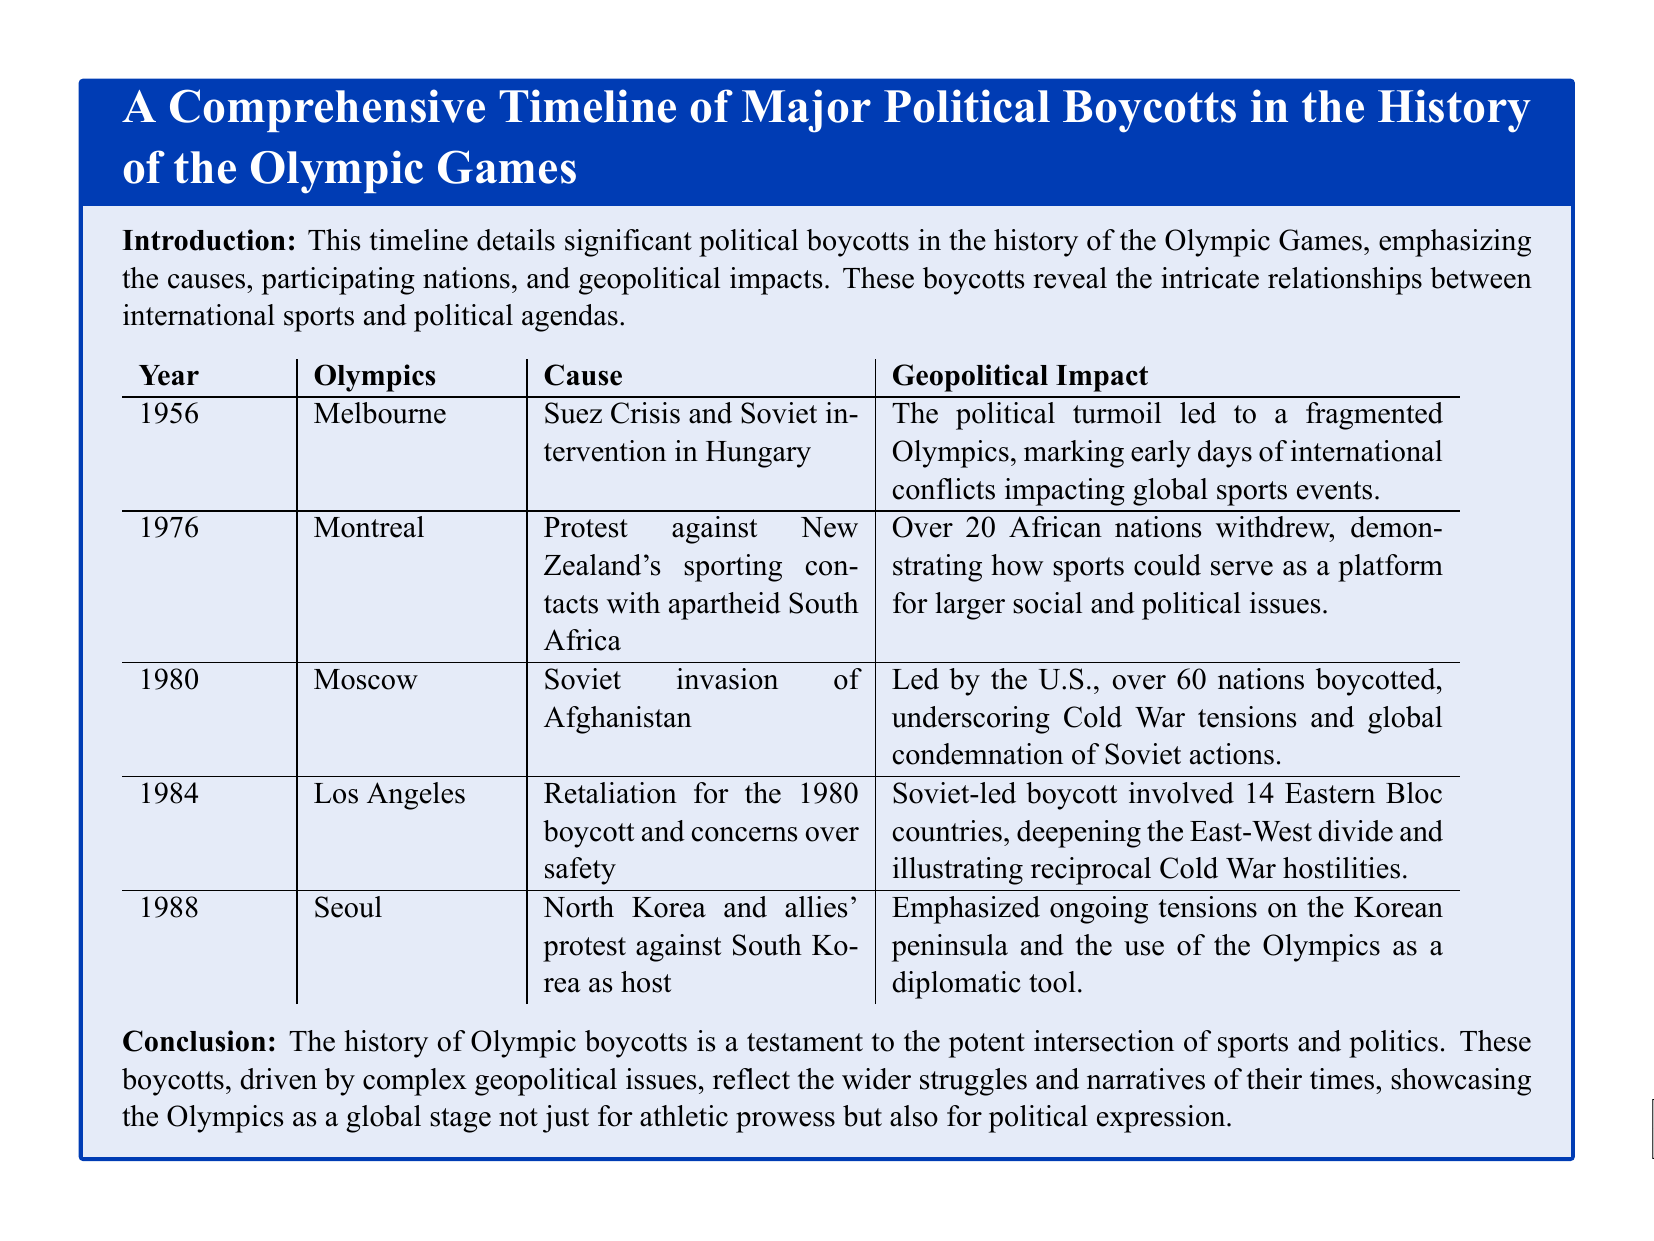What year did the Melbourne Olympics take place? The document specifies that the Melbourne Olympics occurred in 1956.
Answer: 1956 Which political event caused the 1980 Moscow boycott? The document states that the Soviet invasion of Afghanistan was the cause for the boycott in 1980.
Answer: Soviet invasion of Afghanistan How many nations boycotted the 1980 Moscow Olympics? The document indicates that over 60 nations participated in the boycott.
Answer: over 60 nations What was the main reason for the 1976 Montreal boycott? The document highlights that the protest was against New Zealand's sporting contacts with apartheid South Africa.
Answer: New Zealand's sporting contacts with apartheid South Africa Which two Olympic Games were directly related to Cold War tensions? The document mentions the 1980 Moscow and 1984 Los Angeles Olympic Games as having significant Cold War implications.
Answer: 1980 Moscow and 1984 Los Angeles What major geopolitical event occurred in 1956 affecting the Olympics? According to the document, the Suez Crisis and Soviet intervention in Hungary were significant events in 1956.
Answer: Suez Crisis and Soviet intervention in Hungary How did the 1984 Los Angeles boycott impact East-West relations? The document explains that the boycott deepened the East-West divide during the Cold War.
Answer: Deepened the East-West divide Which country led the boycott of the 1980 Moscow Olympics? The document states that the U.S. led the boycott against the Moscow Olympics.
Answer: U.S What was the key outcome of the boycotts discussed in the document? The document concludes that these boycotts highlight the intersection of sports and politics on a global stage.
Answer: Intersection of sports and politics 